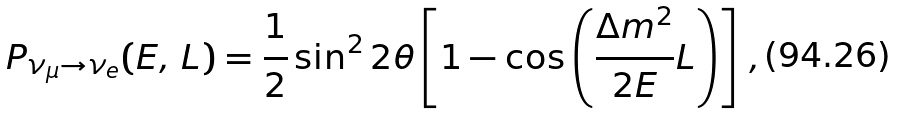Convert formula to latex. <formula><loc_0><loc_0><loc_500><loc_500>P _ { \nu _ { \mu } \rightarrow \nu _ { e } } ( E , \, L ) = \frac { 1 } { 2 } \sin ^ { 2 } 2 \theta \left [ 1 - \cos \left ( \frac { \Delta m ^ { 2 } } { \, 2 E \, } L \right ) \right ] \, ,</formula> 